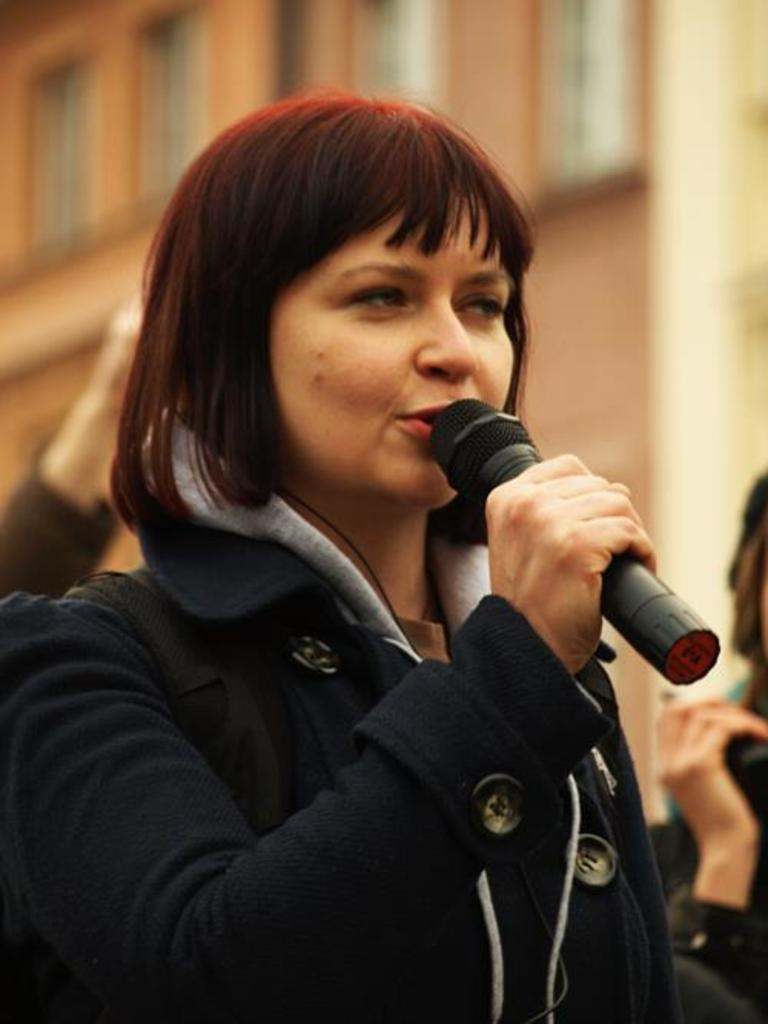Who is the main subject in the image? There is a woman in the image. What is the woman holding in the image? The woman is holding a microphone. What can be seen in the background of the image? There is a building in the background of the image. What is the woman's relation to the stranger in the image? There is no stranger present in the image, so it is not possible to determine the woman's relation to a stranger. 